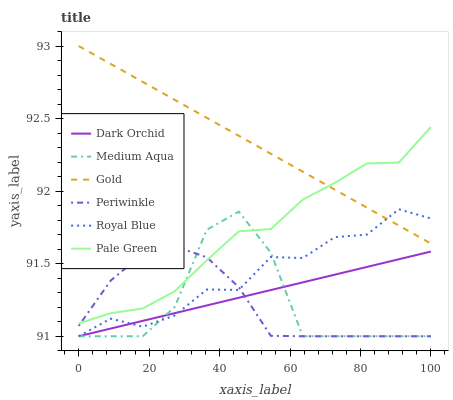Does Medium Aqua have the minimum area under the curve?
Answer yes or no. Yes. Does Gold have the maximum area under the curve?
Answer yes or no. Yes. Does Dark Orchid have the minimum area under the curve?
Answer yes or no. No. Does Dark Orchid have the maximum area under the curve?
Answer yes or no. No. Is Gold the smoothest?
Answer yes or no. Yes. Is Medium Aqua the roughest?
Answer yes or no. Yes. Is Dark Orchid the smoothest?
Answer yes or no. No. Is Dark Orchid the roughest?
Answer yes or no. No. Does Pale Green have the lowest value?
Answer yes or no. No. Does Gold have the highest value?
Answer yes or no. Yes. Does Royal Blue have the highest value?
Answer yes or no. No. Is Periwinkle less than Gold?
Answer yes or no. Yes. Is Gold greater than Medium Aqua?
Answer yes or no. Yes. Does Periwinkle intersect Gold?
Answer yes or no. No. 